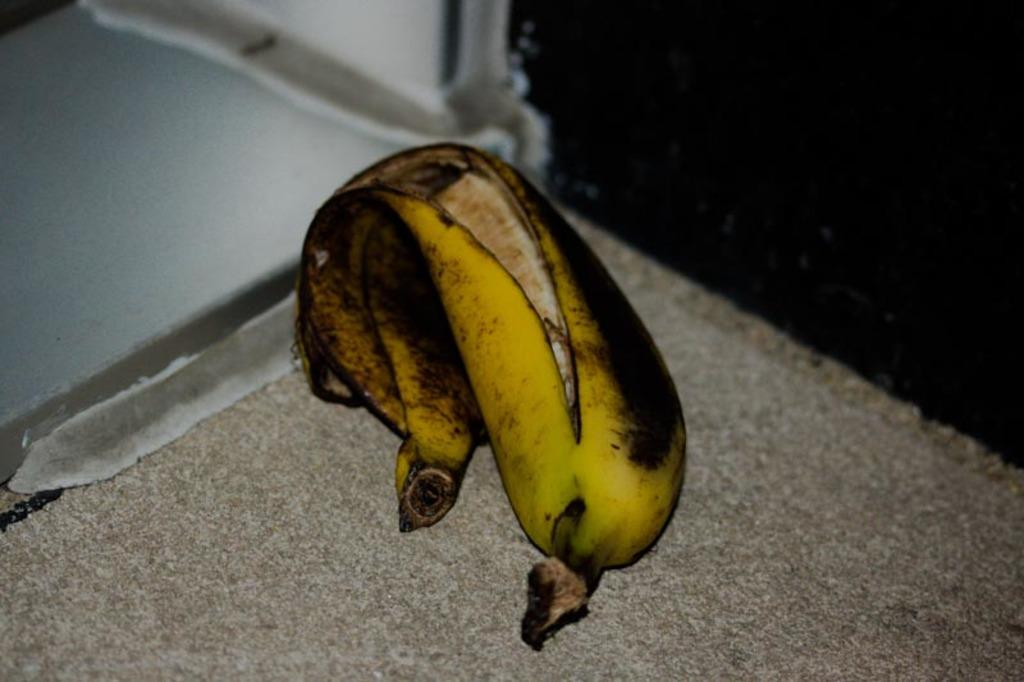What is on the floor in the image? There is a banana on the floor in the image. What color are the eyes of the banana in the image? Bananas do not have eyes, so this question cannot be answered definitively based on the provided facts. 